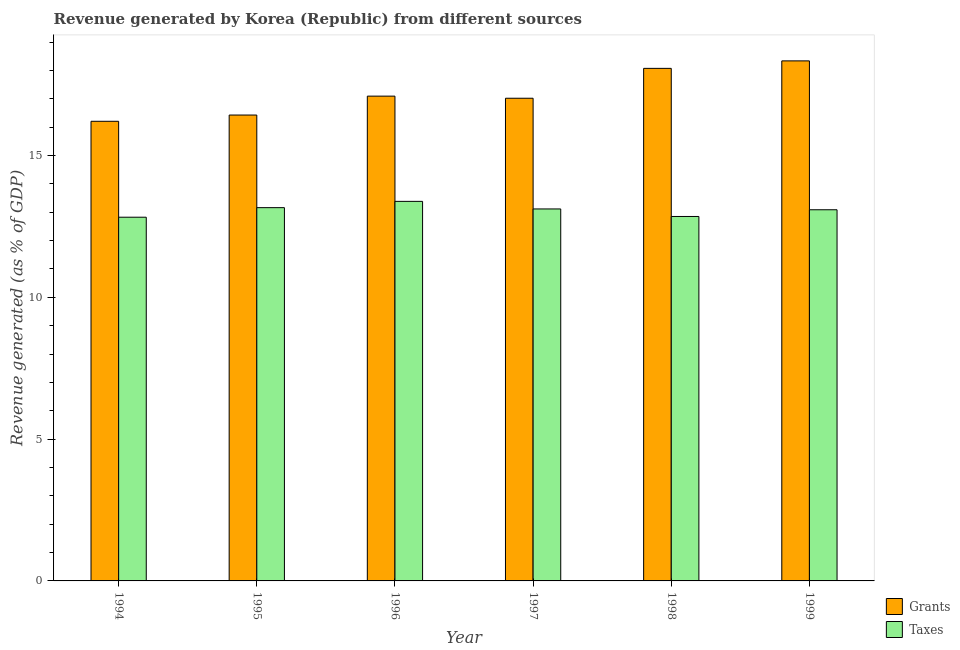How many bars are there on the 3rd tick from the right?
Offer a terse response. 2. What is the label of the 5th group of bars from the left?
Offer a very short reply. 1998. What is the revenue generated by taxes in 1999?
Your answer should be compact. 13.09. Across all years, what is the maximum revenue generated by taxes?
Offer a terse response. 13.38. Across all years, what is the minimum revenue generated by taxes?
Provide a succinct answer. 12.82. In which year was the revenue generated by taxes maximum?
Offer a very short reply. 1996. What is the total revenue generated by grants in the graph?
Provide a succinct answer. 103.15. What is the difference between the revenue generated by grants in 1994 and that in 1995?
Make the answer very short. -0.22. What is the difference between the revenue generated by grants in 1996 and the revenue generated by taxes in 1999?
Offer a terse response. -1.24. What is the average revenue generated by grants per year?
Provide a short and direct response. 17.19. What is the ratio of the revenue generated by grants in 1996 to that in 1997?
Keep it short and to the point. 1. Is the revenue generated by grants in 1994 less than that in 1995?
Your answer should be compact. Yes. Is the difference between the revenue generated by taxes in 1994 and 1999 greater than the difference between the revenue generated by grants in 1994 and 1999?
Ensure brevity in your answer.  No. What is the difference between the highest and the second highest revenue generated by taxes?
Give a very brief answer. 0.22. What is the difference between the highest and the lowest revenue generated by grants?
Provide a succinct answer. 2.13. Is the sum of the revenue generated by grants in 1995 and 1999 greater than the maximum revenue generated by taxes across all years?
Offer a very short reply. Yes. What does the 1st bar from the left in 1999 represents?
Provide a short and direct response. Grants. What does the 2nd bar from the right in 1995 represents?
Offer a very short reply. Grants. How many years are there in the graph?
Offer a very short reply. 6. Are the values on the major ticks of Y-axis written in scientific E-notation?
Make the answer very short. No. Does the graph contain grids?
Make the answer very short. No. Where does the legend appear in the graph?
Your response must be concise. Bottom right. How many legend labels are there?
Provide a succinct answer. 2. What is the title of the graph?
Offer a terse response. Revenue generated by Korea (Republic) from different sources. What is the label or title of the X-axis?
Ensure brevity in your answer.  Year. What is the label or title of the Y-axis?
Make the answer very short. Revenue generated (as % of GDP). What is the Revenue generated (as % of GDP) of Grants in 1994?
Make the answer very short. 16.21. What is the Revenue generated (as % of GDP) in Taxes in 1994?
Offer a very short reply. 12.82. What is the Revenue generated (as % of GDP) in Grants in 1995?
Provide a short and direct response. 16.43. What is the Revenue generated (as % of GDP) in Taxes in 1995?
Offer a terse response. 13.16. What is the Revenue generated (as % of GDP) in Grants in 1996?
Offer a terse response. 17.09. What is the Revenue generated (as % of GDP) of Taxes in 1996?
Make the answer very short. 13.38. What is the Revenue generated (as % of GDP) in Grants in 1997?
Ensure brevity in your answer.  17.02. What is the Revenue generated (as % of GDP) of Taxes in 1997?
Provide a short and direct response. 13.12. What is the Revenue generated (as % of GDP) of Grants in 1998?
Offer a terse response. 18.07. What is the Revenue generated (as % of GDP) of Taxes in 1998?
Your answer should be compact. 12.85. What is the Revenue generated (as % of GDP) of Grants in 1999?
Make the answer very short. 18.34. What is the Revenue generated (as % of GDP) of Taxes in 1999?
Offer a terse response. 13.09. Across all years, what is the maximum Revenue generated (as % of GDP) in Grants?
Your answer should be compact. 18.34. Across all years, what is the maximum Revenue generated (as % of GDP) of Taxes?
Provide a succinct answer. 13.38. Across all years, what is the minimum Revenue generated (as % of GDP) in Grants?
Make the answer very short. 16.21. Across all years, what is the minimum Revenue generated (as % of GDP) of Taxes?
Offer a terse response. 12.82. What is the total Revenue generated (as % of GDP) of Grants in the graph?
Make the answer very short. 103.15. What is the total Revenue generated (as % of GDP) in Taxes in the graph?
Offer a terse response. 78.42. What is the difference between the Revenue generated (as % of GDP) in Grants in 1994 and that in 1995?
Give a very brief answer. -0.22. What is the difference between the Revenue generated (as % of GDP) of Taxes in 1994 and that in 1995?
Provide a short and direct response. -0.34. What is the difference between the Revenue generated (as % of GDP) of Grants in 1994 and that in 1996?
Offer a very short reply. -0.89. What is the difference between the Revenue generated (as % of GDP) in Taxes in 1994 and that in 1996?
Make the answer very short. -0.56. What is the difference between the Revenue generated (as % of GDP) of Grants in 1994 and that in 1997?
Offer a terse response. -0.81. What is the difference between the Revenue generated (as % of GDP) in Taxes in 1994 and that in 1997?
Give a very brief answer. -0.29. What is the difference between the Revenue generated (as % of GDP) of Grants in 1994 and that in 1998?
Your answer should be very brief. -1.87. What is the difference between the Revenue generated (as % of GDP) in Taxes in 1994 and that in 1998?
Keep it short and to the point. -0.03. What is the difference between the Revenue generated (as % of GDP) in Grants in 1994 and that in 1999?
Give a very brief answer. -2.13. What is the difference between the Revenue generated (as % of GDP) of Taxes in 1994 and that in 1999?
Your answer should be compact. -0.26. What is the difference between the Revenue generated (as % of GDP) in Grants in 1995 and that in 1996?
Your answer should be very brief. -0.67. What is the difference between the Revenue generated (as % of GDP) in Taxes in 1995 and that in 1996?
Your answer should be compact. -0.22. What is the difference between the Revenue generated (as % of GDP) of Grants in 1995 and that in 1997?
Your answer should be very brief. -0.59. What is the difference between the Revenue generated (as % of GDP) in Taxes in 1995 and that in 1997?
Your answer should be very brief. 0.05. What is the difference between the Revenue generated (as % of GDP) in Grants in 1995 and that in 1998?
Your answer should be compact. -1.65. What is the difference between the Revenue generated (as % of GDP) of Taxes in 1995 and that in 1998?
Offer a very short reply. 0.31. What is the difference between the Revenue generated (as % of GDP) of Grants in 1995 and that in 1999?
Offer a very short reply. -1.91. What is the difference between the Revenue generated (as % of GDP) of Taxes in 1995 and that in 1999?
Make the answer very short. 0.07. What is the difference between the Revenue generated (as % of GDP) in Grants in 1996 and that in 1997?
Offer a very short reply. 0.07. What is the difference between the Revenue generated (as % of GDP) in Taxes in 1996 and that in 1997?
Offer a very short reply. 0.27. What is the difference between the Revenue generated (as % of GDP) of Grants in 1996 and that in 1998?
Offer a very short reply. -0.98. What is the difference between the Revenue generated (as % of GDP) in Taxes in 1996 and that in 1998?
Offer a terse response. 0.53. What is the difference between the Revenue generated (as % of GDP) in Grants in 1996 and that in 1999?
Your answer should be compact. -1.24. What is the difference between the Revenue generated (as % of GDP) of Taxes in 1996 and that in 1999?
Make the answer very short. 0.3. What is the difference between the Revenue generated (as % of GDP) of Grants in 1997 and that in 1998?
Offer a terse response. -1.05. What is the difference between the Revenue generated (as % of GDP) in Taxes in 1997 and that in 1998?
Ensure brevity in your answer.  0.27. What is the difference between the Revenue generated (as % of GDP) in Grants in 1997 and that in 1999?
Offer a very short reply. -1.32. What is the difference between the Revenue generated (as % of GDP) in Taxes in 1997 and that in 1999?
Provide a succinct answer. 0.03. What is the difference between the Revenue generated (as % of GDP) in Grants in 1998 and that in 1999?
Your answer should be compact. -0.26. What is the difference between the Revenue generated (as % of GDP) in Taxes in 1998 and that in 1999?
Your answer should be compact. -0.24. What is the difference between the Revenue generated (as % of GDP) of Grants in 1994 and the Revenue generated (as % of GDP) of Taxes in 1995?
Provide a succinct answer. 3.04. What is the difference between the Revenue generated (as % of GDP) in Grants in 1994 and the Revenue generated (as % of GDP) in Taxes in 1996?
Give a very brief answer. 2.82. What is the difference between the Revenue generated (as % of GDP) in Grants in 1994 and the Revenue generated (as % of GDP) in Taxes in 1997?
Make the answer very short. 3.09. What is the difference between the Revenue generated (as % of GDP) of Grants in 1994 and the Revenue generated (as % of GDP) of Taxes in 1998?
Your answer should be very brief. 3.36. What is the difference between the Revenue generated (as % of GDP) in Grants in 1994 and the Revenue generated (as % of GDP) in Taxes in 1999?
Your answer should be very brief. 3.12. What is the difference between the Revenue generated (as % of GDP) in Grants in 1995 and the Revenue generated (as % of GDP) in Taxes in 1996?
Provide a short and direct response. 3.04. What is the difference between the Revenue generated (as % of GDP) of Grants in 1995 and the Revenue generated (as % of GDP) of Taxes in 1997?
Ensure brevity in your answer.  3.31. What is the difference between the Revenue generated (as % of GDP) in Grants in 1995 and the Revenue generated (as % of GDP) in Taxes in 1998?
Offer a terse response. 3.58. What is the difference between the Revenue generated (as % of GDP) in Grants in 1995 and the Revenue generated (as % of GDP) in Taxes in 1999?
Offer a terse response. 3.34. What is the difference between the Revenue generated (as % of GDP) of Grants in 1996 and the Revenue generated (as % of GDP) of Taxes in 1997?
Offer a very short reply. 3.98. What is the difference between the Revenue generated (as % of GDP) of Grants in 1996 and the Revenue generated (as % of GDP) of Taxes in 1998?
Offer a terse response. 4.24. What is the difference between the Revenue generated (as % of GDP) in Grants in 1996 and the Revenue generated (as % of GDP) in Taxes in 1999?
Provide a short and direct response. 4.01. What is the difference between the Revenue generated (as % of GDP) in Grants in 1997 and the Revenue generated (as % of GDP) in Taxes in 1998?
Make the answer very short. 4.17. What is the difference between the Revenue generated (as % of GDP) of Grants in 1997 and the Revenue generated (as % of GDP) of Taxes in 1999?
Ensure brevity in your answer.  3.93. What is the difference between the Revenue generated (as % of GDP) in Grants in 1998 and the Revenue generated (as % of GDP) in Taxes in 1999?
Ensure brevity in your answer.  4.99. What is the average Revenue generated (as % of GDP) of Grants per year?
Ensure brevity in your answer.  17.19. What is the average Revenue generated (as % of GDP) of Taxes per year?
Ensure brevity in your answer.  13.07. In the year 1994, what is the difference between the Revenue generated (as % of GDP) of Grants and Revenue generated (as % of GDP) of Taxes?
Provide a succinct answer. 3.38. In the year 1995, what is the difference between the Revenue generated (as % of GDP) of Grants and Revenue generated (as % of GDP) of Taxes?
Give a very brief answer. 3.27. In the year 1996, what is the difference between the Revenue generated (as % of GDP) of Grants and Revenue generated (as % of GDP) of Taxes?
Offer a very short reply. 3.71. In the year 1997, what is the difference between the Revenue generated (as % of GDP) in Grants and Revenue generated (as % of GDP) in Taxes?
Provide a succinct answer. 3.9. In the year 1998, what is the difference between the Revenue generated (as % of GDP) of Grants and Revenue generated (as % of GDP) of Taxes?
Provide a succinct answer. 5.22. In the year 1999, what is the difference between the Revenue generated (as % of GDP) of Grants and Revenue generated (as % of GDP) of Taxes?
Offer a terse response. 5.25. What is the ratio of the Revenue generated (as % of GDP) of Grants in 1994 to that in 1995?
Make the answer very short. 0.99. What is the ratio of the Revenue generated (as % of GDP) of Taxes in 1994 to that in 1995?
Keep it short and to the point. 0.97. What is the ratio of the Revenue generated (as % of GDP) of Grants in 1994 to that in 1996?
Make the answer very short. 0.95. What is the ratio of the Revenue generated (as % of GDP) in Taxes in 1994 to that in 1996?
Ensure brevity in your answer.  0.96. What is the ratio of the Revenue generated (as % of GDP) in Grants in 1994 to that in 1997?
Ensure brevity in your answer.  0.95. What is the ratio of the Revenue generated (as % of GDP) of Taxes in 1994 to that in 1997?
Keep it short and to the point. 0.98. What is the ratio of the Revenue generated (as % of GDP) of Grants in 1994 to that in 1998?
Your response must be concise. 0.9. What is the ratio of the Revenue generated (as % of GDP) in Grants in 1994 to that in 1999?
Provide a succinct answer. 0.88. What is the ratio of the Revenue generated (as % of GDP) of Taxes in 1994 to that in 1999?
Give a very brief answer. 0.98. What is the ratio of the Revenue generated (as % of GDP) in Taxes in 1995 to that in 1996?
Your answer should be compact. 0.98. What is the ratio of the Revenue generated (as % of GDP) of Grants in 1995 to that in 1997?
Your answer should be compact. 0.97. What is the ratio of the Revenue generated (as % of GDP) of Taxes in 1995 to that in 1997?
Give a very brief answer. 1. What is the ratio of the Revenue generated (as % of GDP) of Grants in 1995 to that in 1998?
Make the answer very short. 0.91. What is the ratio of the Revenue generated (as % of GDP) in Taxes in 1995 to that in 1998?
Give a very brief answer. 1.02. What is the ratio of the Revenue generated (as % of GDP) in Grants in 1995 to that in 1999?
Provide a short and direct response. 0.9. What is the ratio of the Revenue generated (as % of GDP) in Taxes in 1995 to that in 1999?
Ensure brevity in your answer.  1.01. What is the ratio of the Revenue generated (as % of GDP) in Taxes in 1996 to that in 1997?
Provide a succinct answer. 1.02. What is the ratio of the Revenue generated (as % of GDP) in Grants in 1996 to that in 1998?
Your response must be concise. 0.95. What is the ratio of the Revenue generated (as % of GDP) in Taxes in 1996 to that in 1998?
Provide a short and direct response. 1.04. What is the ratio of the Revenue generated (as % of GDP) of Grants in 1996 to that in 1999?
Ensure brevity in your answer.  0.93. What is the ratio of the Revenue generated (as % of GDP) of Taxes in 1996 to that in 1999?
Your answer should be very brief. 1.02. What is the ratio of the Revenue generated (as % of GDP) of Grants in 1997 to that in 1998?
Make the answer very short. 0.94. What is the ratio of the Revenue generated (as % of GDP) of Taxes in 1997 to that in 1998?
Offer a very short reply. 1.02. What is the ratio of the Revenue generated (as % of GDP) in Grants in 1997 to that in 1999?
Your answer should be very brief. 0.93. What is the ratio of the Revenue generated (as % of GDP) of Grants in 1998 to that in 1999?
Your answer should be very brief. 0.99. What is the ratio of the Revenue generated (as % of GDP) in Taxes in 1998 to that in 1999?
Make the answer very short. 0.98. What is the difference between the highest and the second highest Revenue generated (as % of GDP) of Grants?
Your answer should be compact. 0.26. What is the difference between the highest and the second highest Revenue generated (as % of GDP) of Taxes?
Offer a terse response. 0.22. What is the difference between the highest and the lowest Revenue generated (as % of GDP) of Grants?
Give a very brief answer. 2.13. What is the difference between the highest and the lowest Revenue generated (as % of GDP) of Taxes?
Your answer should be compact. 0.56. 